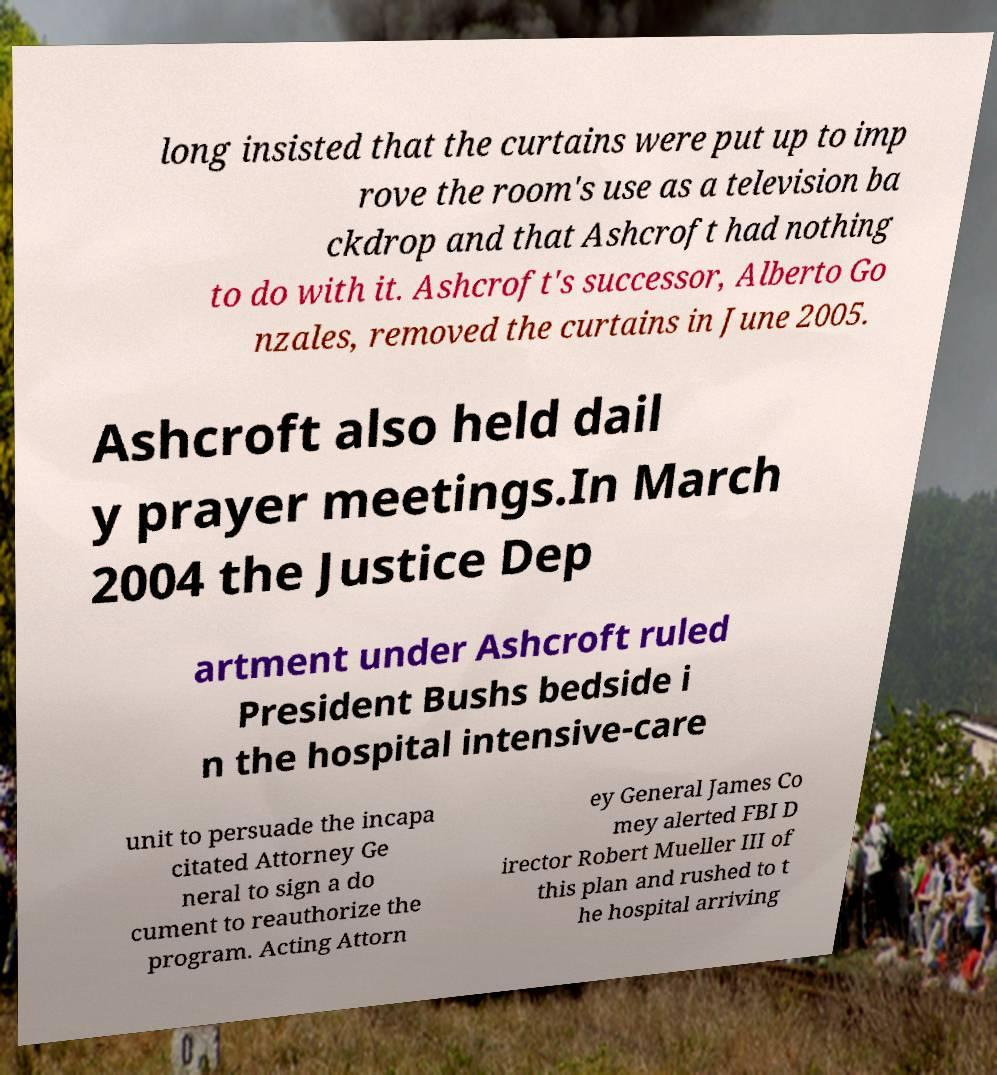I need the written content from this picture converted into text. Can you do that? long insisted that the curtains were put up to imp rove the room's use as a television ba ckdrop and that Ashcroft had nothing to do with it. Ashcroft's successor, Alberto Go nzales, removed the curtains in June 2005. Ashcroft also held dail y prayer meetings.In March 2004 the Justice Dep artment under Ashcroft ruled President Bushs bedside i n the hospital intensive-care unit to persuade the incapa citated Attorney Ge neral to sign a do cument to reauthorize the program. Acting Attorn ey General James Co mey alerted FBI D irector Robert Mueller III of this plan and rushed to t he hospital arriving 